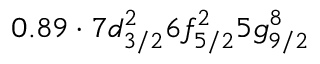Convert formula to latex. <formula><loc_0><loc_0><loc_500><loc_500>0 . 8 9 \cdot 7 d _ { 3 / 2 } ^ { 2 } 6 f _ { 5 / 2 } ^ { 2 } 5 g _ { 9 / 2 } ^ { 8 }</formula> 